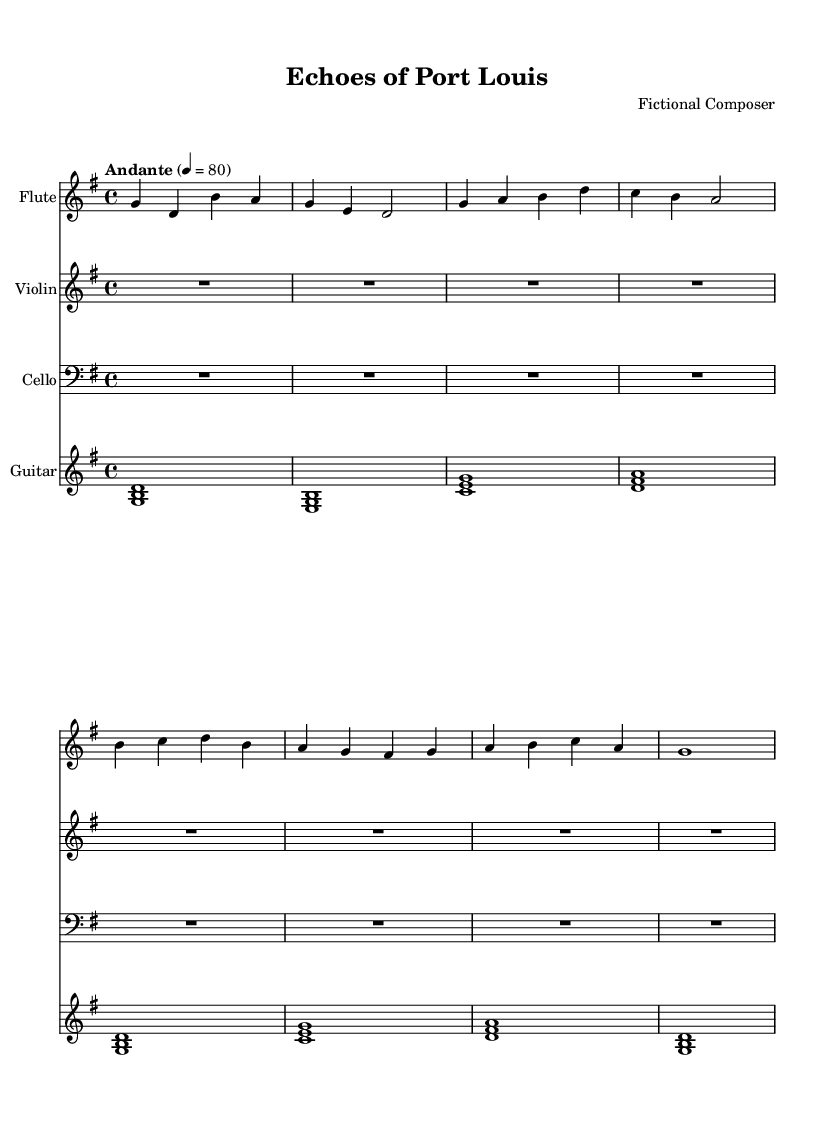What is the key signature of this music? The key signature of the music is indicated by the symbols at the beginning of the staff. In this case, there are no sharps or flats, which signifies that it is in G major.
Answer: G major What is the time signature of this music? The time signature is found at the beginning of the staff, represented by a fraction. Here it is indicated as 4/4, which means there are four beats in a measure and the quarter note gets one beat.
Answer: 4/4 What is the tempo marking of this piece? The tempo marking is indicated above the staff, showing how fast the piece should be played. In this score, the marking "Andante" signifies a moderately slow tempo.
Answer: Andante How many measures are in the flute part? To find the number of measures in the flute part, count the measure bars present in that particular line of music. In this case, there are a total of eight measures in the flute part.
Answer: 8 Which instruments are featured in this score? The instruments are listed at the beginning of each staff, and from the score, they include flute, violin, cello, and guitar.
Answer: Flute, violin, cello, guitar What is the rhythm pattern of the flute in the first measure? The first measure has four notes: G, D, B, and A, each of which is a quarter note, indicating a simple rhythmic pattern with one note per beat.
Answer: Quarter notes What style or thematic element does this soundtrack represent? The title "Echoes of Port Louis" suggests a connection to Mauritian history and culture, likely evoking the memories of colonial-era Mauritius. This aspect is inherent in the title and composition style.
Answer: Historical soundtrack 